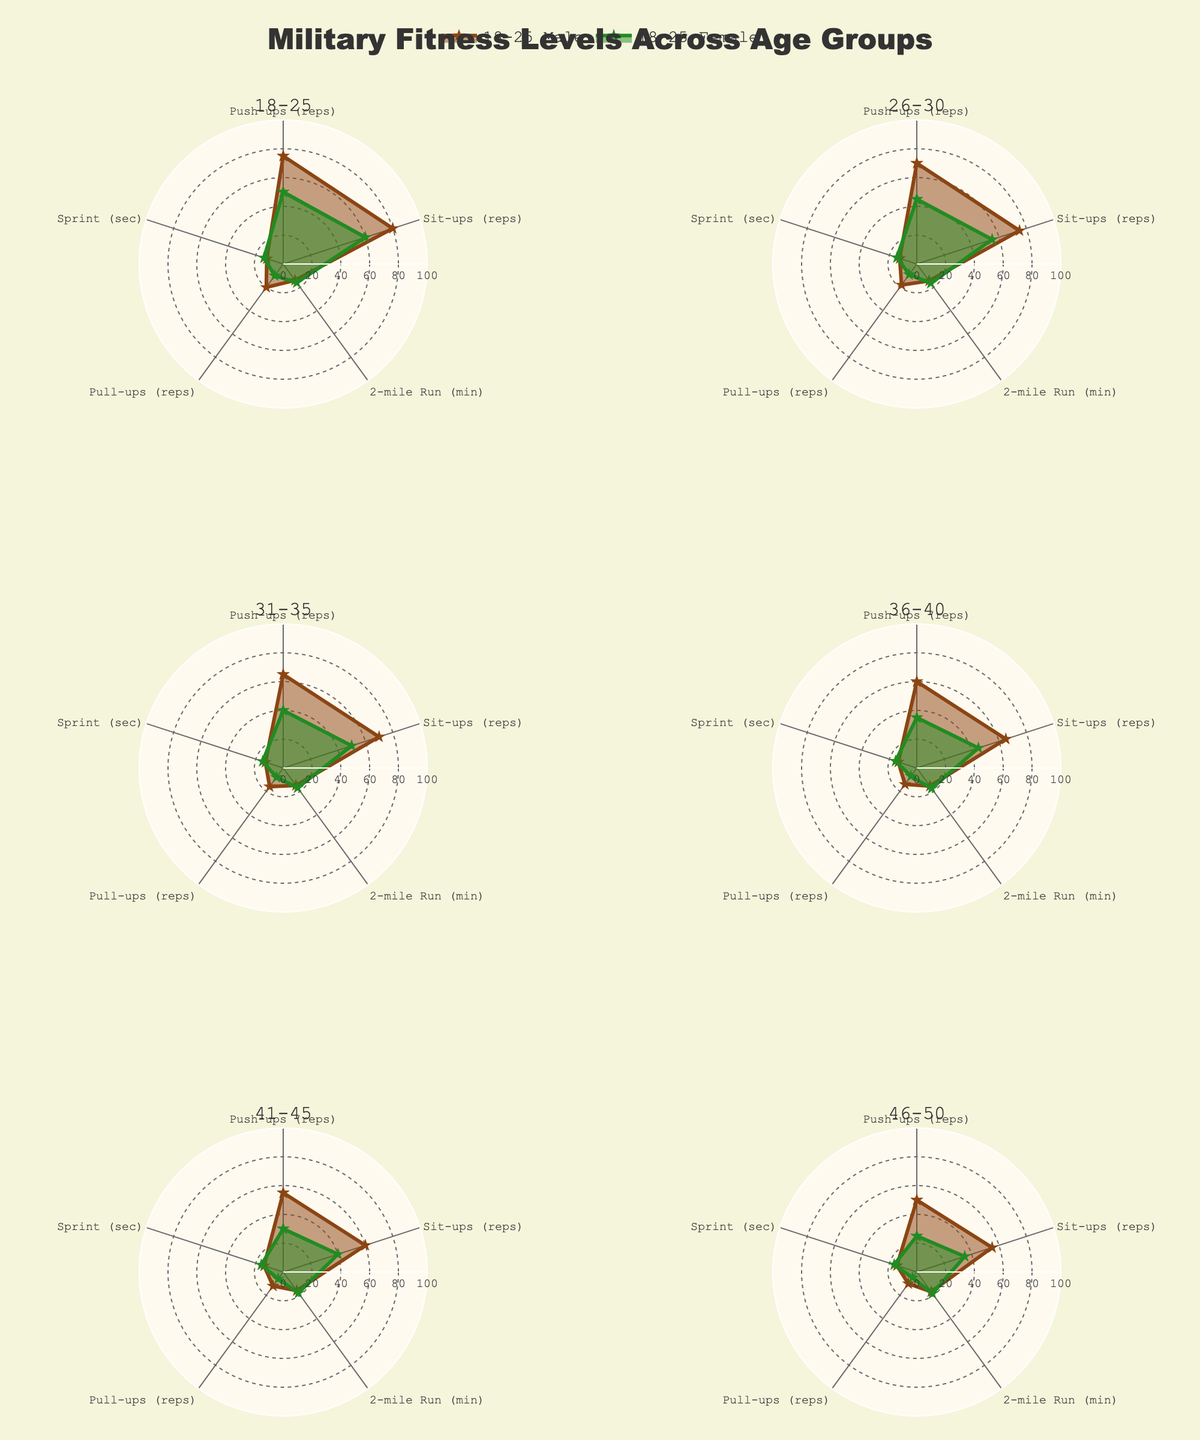Which age group shows the highest number of push-ups for males? By examining the subplot titled "18-25", look for the highest value at the "Push-ups (reps)" point. The highest peak indicates 75 push-ups for males aged 18-25.
Answer: 18-25 How do the 2-mile run times compare between the youngest and oldest female age groups? Check the subplots for the 18-25 and 46-50 age groups. Note the values at the "2-mile Run (min)" point. The times are 16 minutes for the 18-25 group and 18.5 minutes for the 46-50 group.
Answer: The oldest group is slower Which age group and category have the most similar performance in the "Sprint (sec)" metric? Compare the values at the "Sprint (sec)" point across all subplots. Notice that the 18-25 and 26-30 groups for both genders have similar values of 12-14 seconds.
Answer: 18-25 & 26-30 What's the overall trend in pull-up performance for males as age increases? Track the "Pull-ups (reps)" values across subplots for male categories from 18-25 to 46-50. The general trend is a decrease in reps from 20 to 10.
Answer: Decreasing Which age group has the widest disparity in performance between males and females for the "Sit-ups (reps)" metric? Look at the "Sit-ups (reps)" values across all age groups. The 18-25 age group shows a larger difference: males at 80 and females at 60.
Answer: 18-25 How does the average number of push-ups compare between males and females in the 31-35 age group? Check the "Push-ups (reps)" values for the 31-35 age group: 65 for males and 40 for females. Average for males = 65, for females = 40.
Answer: Males perform more on average Are sit-up performances consistent across different age groups for males? Review the "Sit-ups (reps)" values for males across all age groups. Notice a gradual decline from 80 to 55.
Answer: Gradual decrease What's the median value of pull-ups for females aged 26-35? Check the "Pull-ups (reps)" values for females in the 26-30 and 31-35 age groups, which are 9 and 8 respectively. Median value is the average of 9 and 8 = 8.5.
Answer: 8.5 Which age group shows the biggest drop in the 2-mile run performance from the previous age group for males? Compare "2-mile Run (min)" values for males across age groups. Notice the biggest difference between the 41-45 group (16 mins) and the 46-50 group (17 mins).
Answer: 46-50 In which age group do females have the least decrease in physical performance metrics compared to males? By comparing values for all metrics between genders across age groups, the 18-25 group displays the smallest average difference across all metrics.
Answer: 18-25 